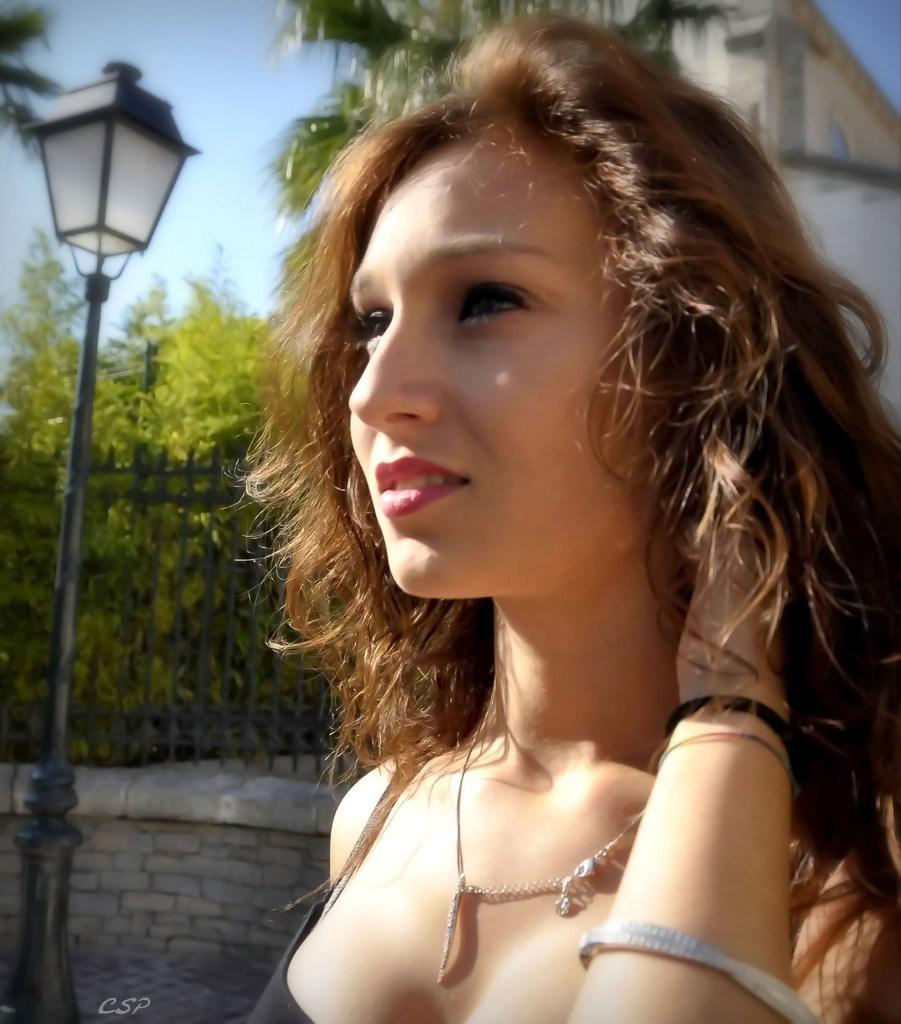Could you give a brief overview of what you see in this image? In this image in front there is a girl. Behind her there is a street light. On the backside there is a metal fence. In the background there are trees, sky and a building. 